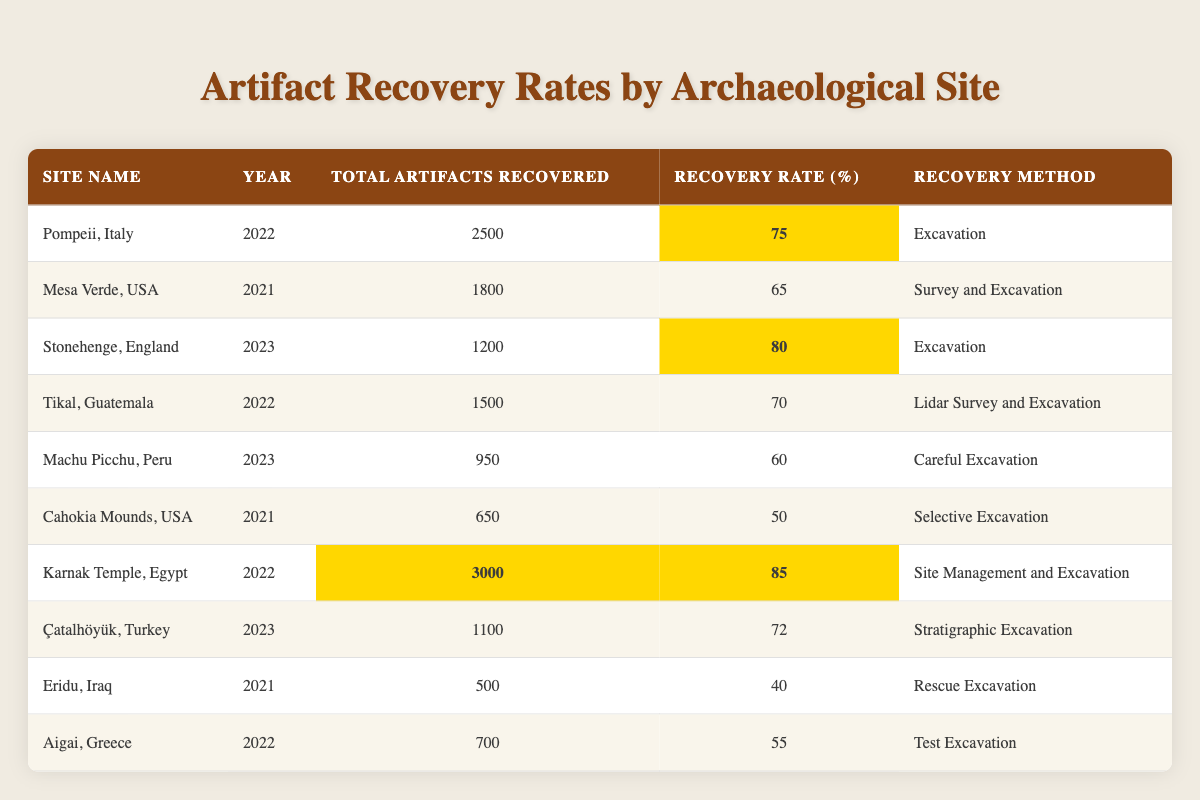What is the recovery rate for Karnak Temple, Egypt? The recovery rate for Karnak Temple, Egypt is indicated in the table under the "Recovery Rate (%)" column, which shows a value of 85%.
Answer: 85% How many artifacts were recovered from Stonehenge, England in 2023? The total artifacts recovered from Stonehenge, England for the year 2023 is directly listed in the table under the "Total Artifacts Recovered" column, showing a value of 1200.
Answer: 1200 Which site had the highest number of artifacts recovered and what was that number? By comparing the "Total Artifacts Recovered" for all sites in the table, Karnak Temple, Egypt shows the highest number with 3000 artifacts.
Answer: 3000 What is the recovery rate for Machu Picchu, Peru in 2023? The recovery rate for Machu Picchu, Peru is displayed in the "Recovery Rate (%)" column, which lists a rate of 60%.
Answer: 60% Which site had a recovery rate of 40% and what was the year of recovery? By searching the table, Eridu, Iraq is identified with a recovery rate of 40%, which occurred in 2021.
Answer: Eridu, Iraq, 2021 What is the average recovery rate across all sites listed in the table? The recovery rates are: 75, 65, 80, 70, 60, 50, 85, 72, 40, 55. Adding these gives a total of 732. Dividing by the number of sites (10), the average recovery rate is 73.2%.
Answer: 73.2% Did any site achieve a recovery rate above 80%? By examining the "Recovery Rate (%)" column, it can be seen that Karnak Temple, Egypt (85%) and Stonehenge, England (80%) show recovery rates above 80%.
Answer: Yes Which site had the lowest recovery rate and how many artifacts were recovered? The table indicates that Eridu, Iraq has the lowest recovery rate of 40%, with 500 artifacts recovered.
Answer: Eridu, Iraq, 500 If we sum the total artifacts recovered from all sites, what is the total? Adding the total artifacts recovered from each site gives: 2500 + 1800 + 1200 + 1500 + 950 + 650 + 3000 + 1100 + 500 + 700 = 12600.
Answer: 12600 Which recovery method was used at Tikal, Guatemala? The "Recovery Method" column specifies that Tikal, Guatemala used "Lidar Survey and Excavation" as its recovery method.
Answer: Lidar Survey and Excavation Is there a site with a recovery rate of 65%? If so, which site is it? Yes, by checking the table, Mesa Verde, USA has a recovery rate of 65%.
Answer: Yes, Mesa Verde, USA 